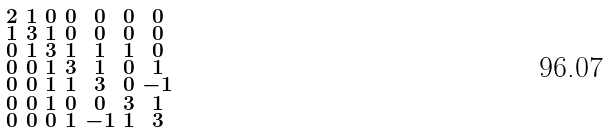Convert formula to latex. <formula><loc_0><loc_0><loc_500><loc_500>\begin{smallmatrix} 2 & 1 & 0 & 0 & 0 & 0 & 0 \\ 1 & 3 & 1 & 0 & 0 & 0 & 0 \\ 0 & 1 & 3 & 1 & 1 & 1 & 0 \\ 0 & 0 & 1 & 3 & 1 & 0 & 1 \\ 0 & 0 & 1 & 1 & 3 & 0 & - 1 \\ 0 & 0 & 1 & 0 & 0 & 3 & 1 \\ 0 & 0 & 0 & 1 & - 1 & 1 & 3 \end{smallmatrix}</formula> 